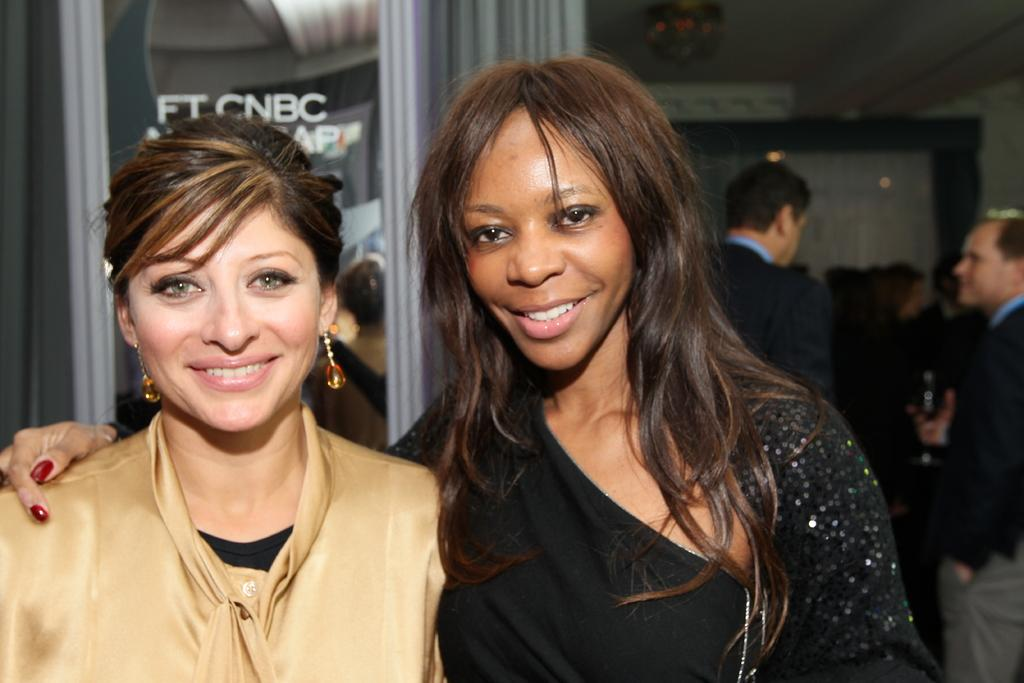How many women are present in the image? There are two women standing in the image. Can you describe the women's positions or actions in the image? The provided facts do not mention the women's positions or actions. What can be seen in the background of the image? In the background of the image, there are people standing. Are there any bees or jellyfish visible in the image? No, there are no bees or jellyfish present in the image. 